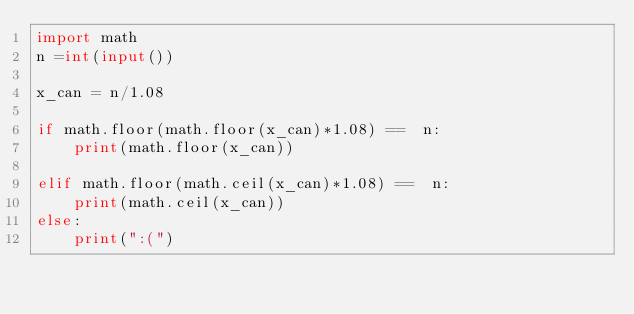<code> <loc_0><loc_0><loc_500><loc_500><_Python_>import math
n =int(input())

x_can = n/1.08

if math.floor(math.floor(x_can)*1.08) ==  n:
    print(math.floor(x_can))

elif math.floor(math.ceil(x_can)*1.08) ==  n:
    print(math.ceil(x_can))
else:
    print(":(")</code> 